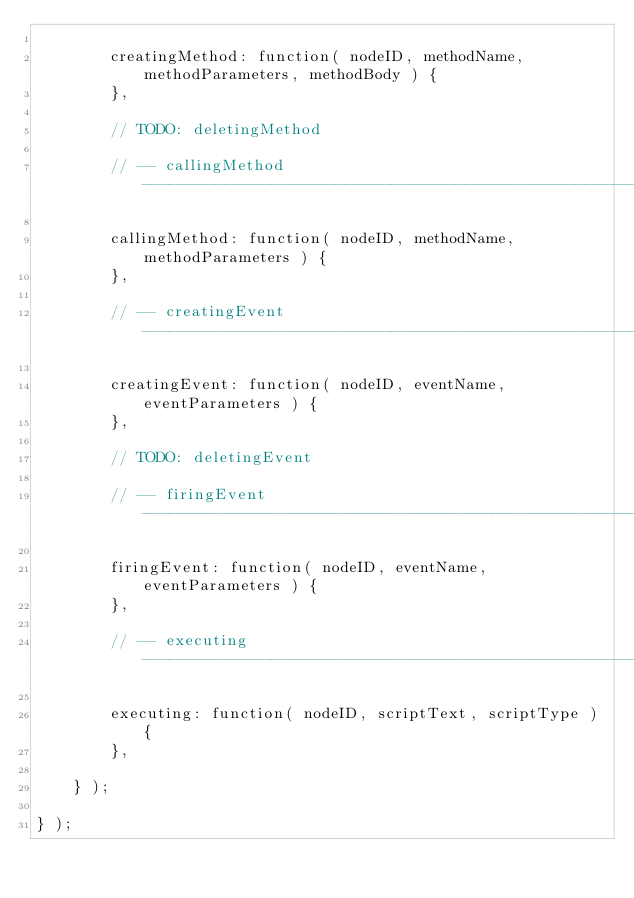<code> <loc_0><loc_0><loc_500><loc_500><_JavaScript_>
        creatingMethod: function( nodeID, methodName, methodParameters, methodBody ) {
        },

        // TODO: deletingMethod

        // -- callingMethod ------------------------------------------------------------------------

        callingMethod: function( nodeID, methodName, methodParameters ) {
        },

        // -- creatingEvent ------------------------------------------------------------------------

        creatingEvent: function( nodeID, eventName, eventParameters ) {
        },

        // TODO: deletingEvent

        // -- firingEvent --------------------------------------------------------------------------

        firingEvent: function( nodeID, eventName, eventParameters ) {
        },

        // -- executing ----------------------------------------------------------------------------

        executing: function( nodeID, scriptText, scriptType ) {
        },

    } );

} );
</code> 